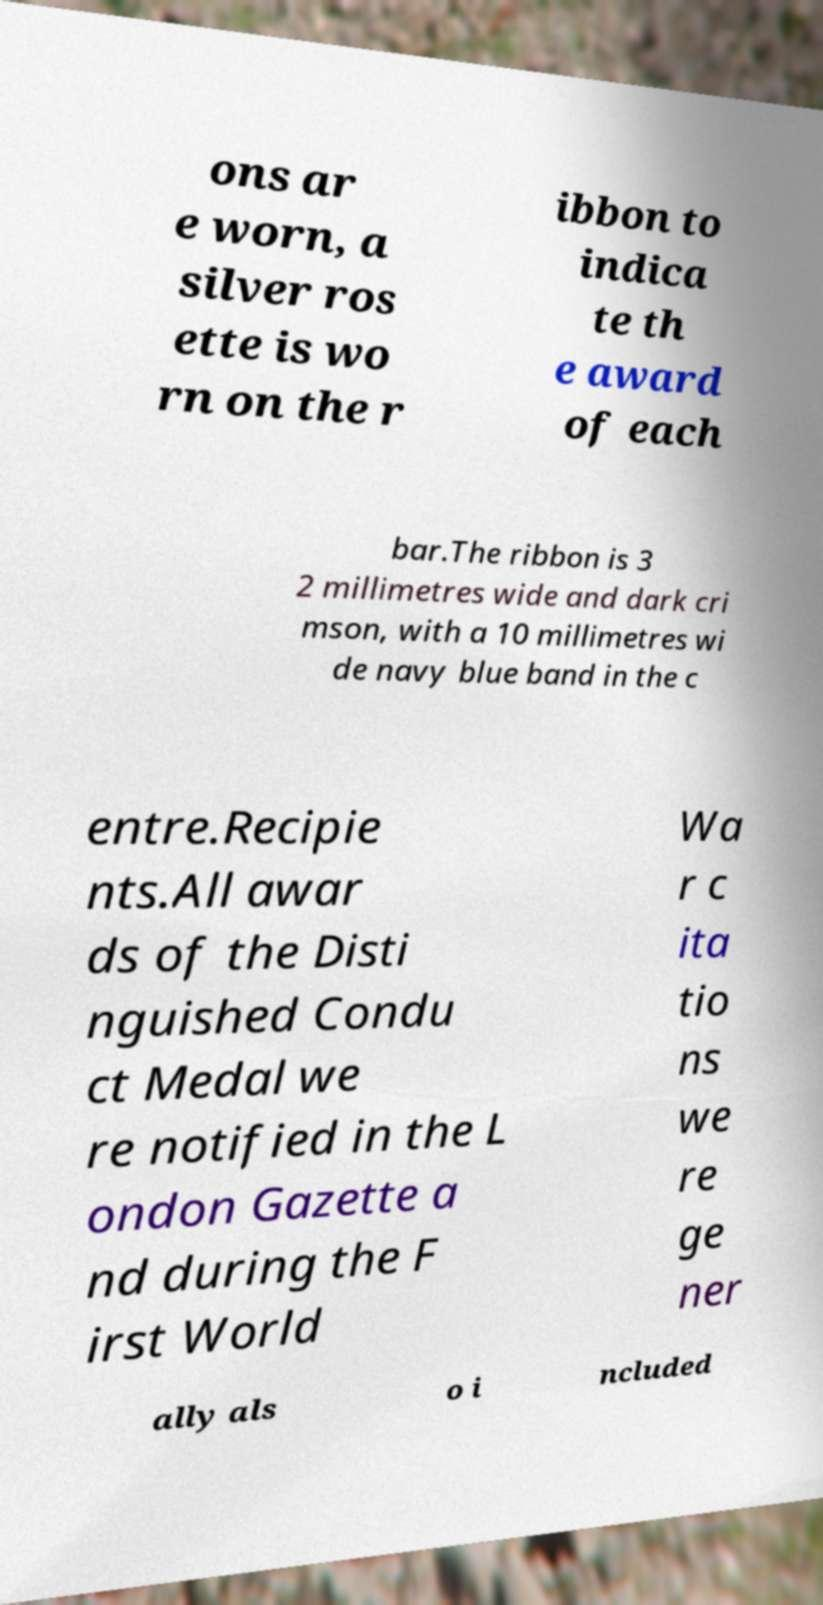For documentation purposes, I need the text within this image transcribed. Could you provide that? ons ar e worn, a silver ros ette is wo rn on the r ibbon to indica te th e award of each bar.The ribbon is 3 2 millimetres wide and dark cri mson, with a 10 millimetres wi de navy blue band in the c entre.Recipie nts.All awar ds of the Disti nguished Condu ct Medal we re notified in the L ondon Gazette a nd during the F irst World Wa r c ita tio ns we re ge ner ally als o i ncluded 